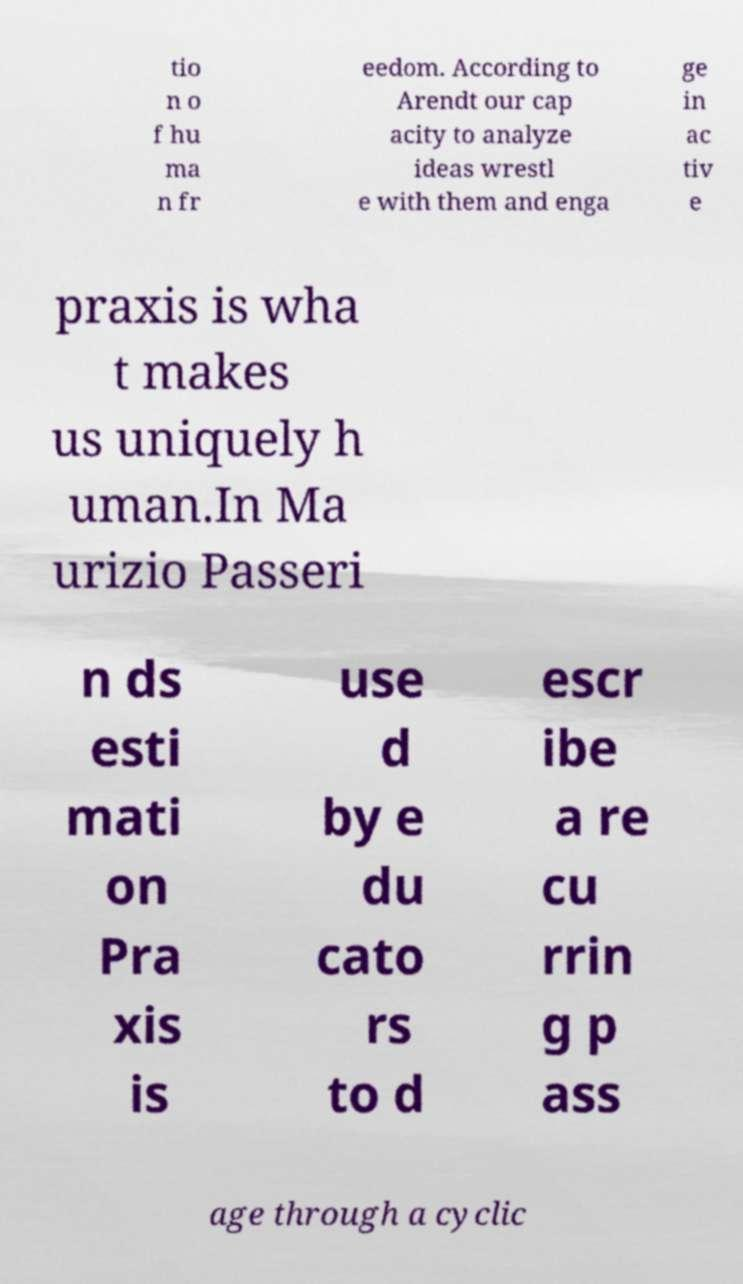Can you read and provide the text displayed in the image?This photo seems to have some interesting text. Can you extract and type it out for me? tio n o f hu ma n fr eedom. According to Arendt our cap acity to analyze ideas wrestl e with them and enga ge in ac tiv e praxis is wha t makes us uniquely h uman.In Ma urizio Passeri n ds esti mati on Pra xis is use d by e du cato rs to d escr ibe a re cu rrin g p ass age through a cyclic 